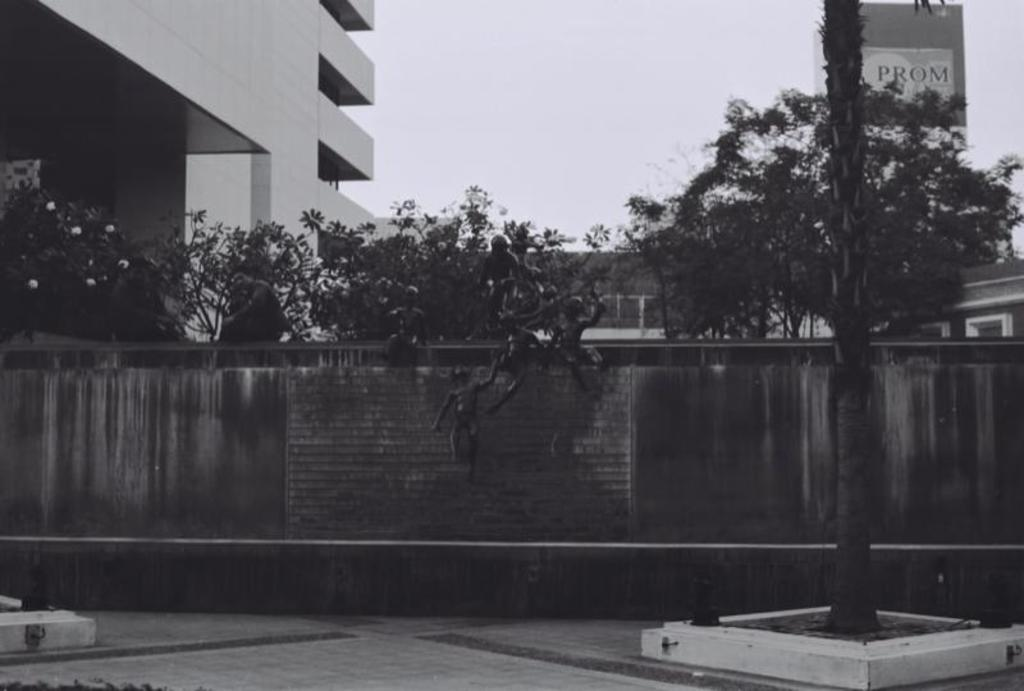What type of structure is located on the left side of the image? There is a building on the left side of the image. What can be seen in the image besides the building? There is a wall and trees visible in the image. What is visible at the top of the image? The sky is visible at the top of the image. Can you tell me how many monkeys are climbing the wall in the image? There are no monkeys present in the image; it features a wall, trees, and a building. What grade of mountain can be seen in the image? There is no mountain present in the image. 